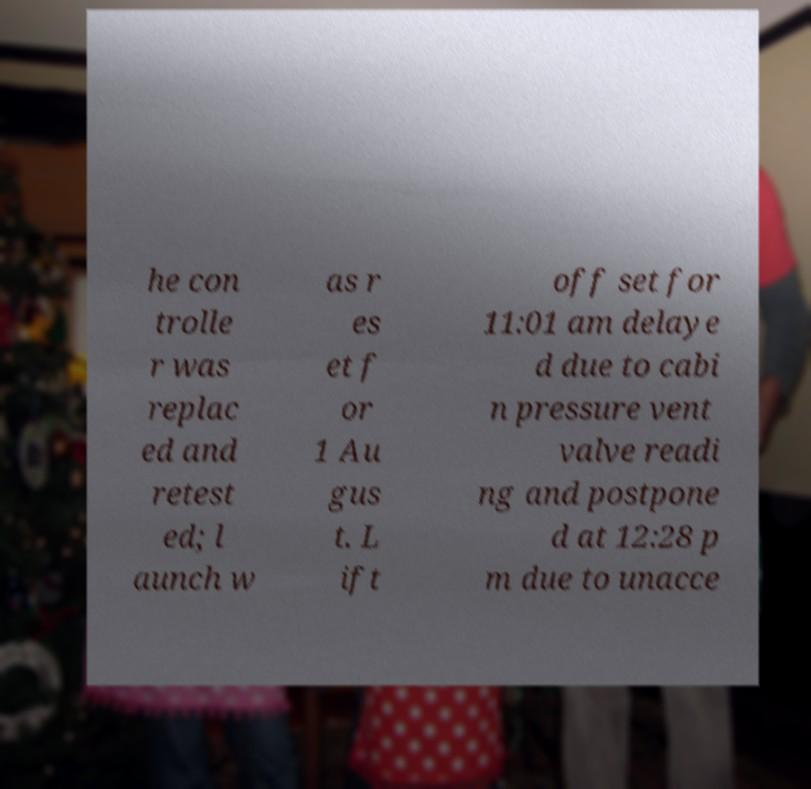Can you accurately transcribe the text from the provided image for me? he con trolle r was replac ed and retest ed; l aunch w as r es et f or 1 Au gus t. L ift off set for 11:01 am delaye d due to cabi n pressure vent valve readi ng and postpone d at 12:28 p m due to unacce 